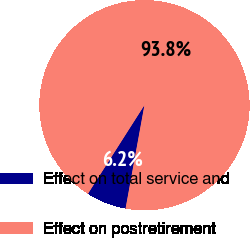Convert chart. <chart><loc_0><loc_0><loc_500><loc_500><pie_chart><fcel>Effect on total service and<fcel>Effect on postretirement<nl><fcel>6.16%<fcel>93.84%<nl></chart> 